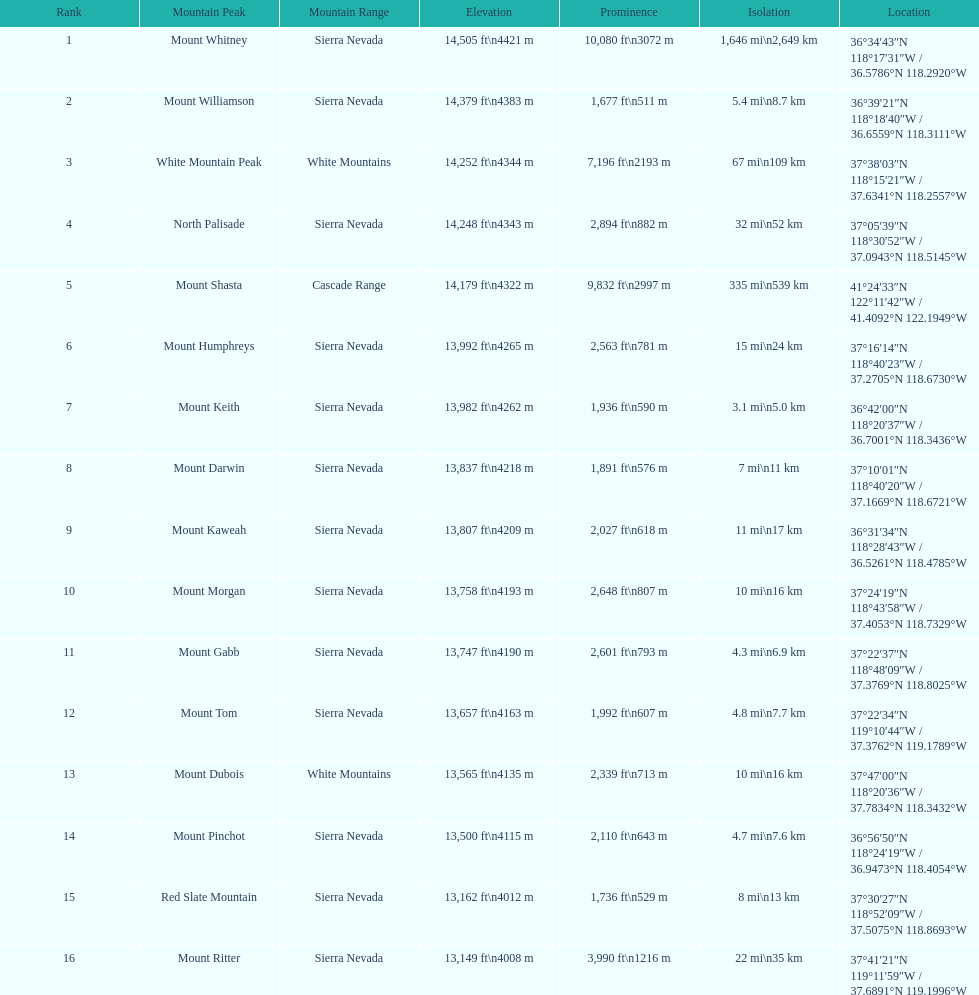What is the tallest peak in the sierra nevadas? Mount Whitney. 